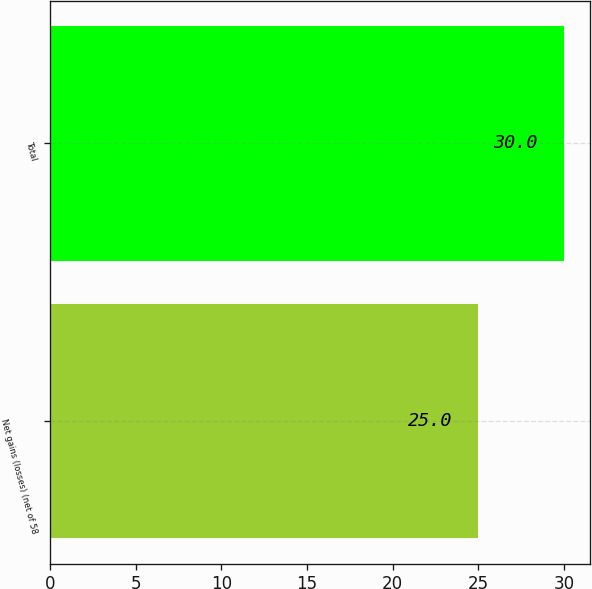Convert chart. <chart><loc_0><loc_0><loc_500><loc_500><bar_chart><fcel>Net gains (losses) (net of 58<fcel>Total<nl><fcel>25<fcel>30<nl></chart> 